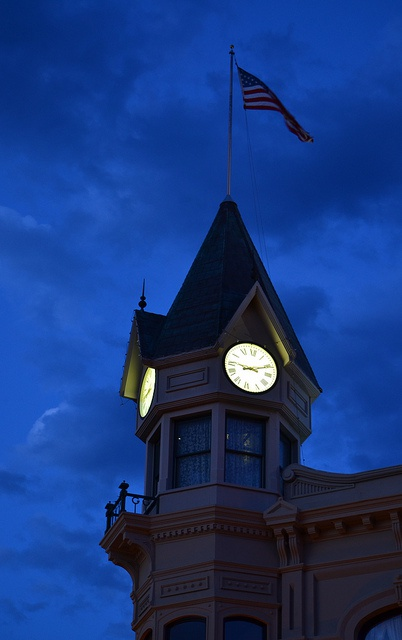Describe the objects in this image and their specific colors. I can see clock in navy, ivory, khaki, black, and olive tones and clock in navy, beige, and khaki tones in this image. 